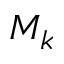Convert formula to latex. <formula><loc_0><loc_0><loc_500><loc_500>M _ { k }</formula> 